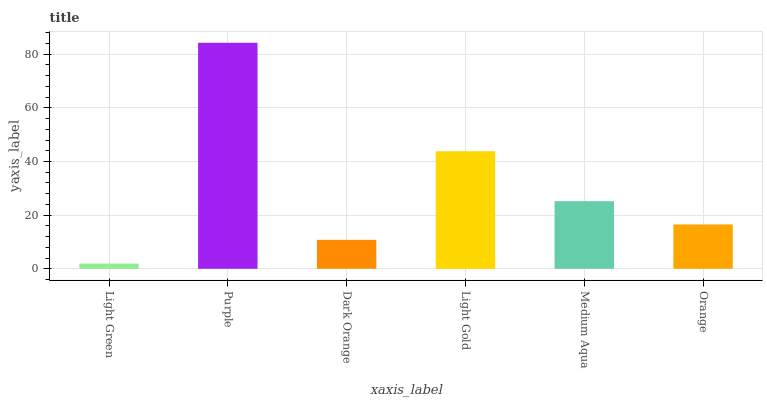Is Light Green the minimum?
Answer yes or no. Yes. Is Purple the maximum?
Answer yes or no. Yes. Is Dark Orange the minimum?
Answer yes or no. No. Is Dark Orange the maximum?
Answer yes or no. No. Is Purple greater than Dark Orange?
Answer yes or no. Yes. Is Dark Orange less than Purple?
Answer yes or no. Yes. Is Dark Orange greater than Purple?
Answer yes or no. No. Is Purple less than Dark Orange?
Answer yes or no. No. Is Medium Aqua the high median?
Answer yes or no. Yes. Is Orange the low median?
Answer yes or no. Yes. Is Orange the high median?
Answer yes or no. No. Is Medium Aqua the low median?
Answer yes or no. No. 